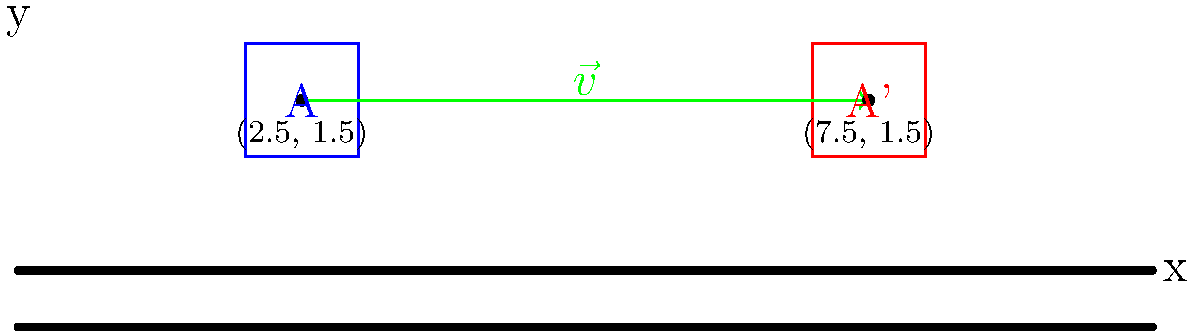A robotic gripper is initially positioned at point A(2.5, 1.5) on a conveyor belt system. The gripper needs to be translated to a new position A'(7.5, 1.5) to pick up an object. Determine the translation vector $\vec{v}$ that describes this movement and express it in component form. To find the translation vector $\vec{v}$, we need to follow these steps:

1) The translation vector $\vec{v}$ is the vector that moves the gripper from point A to point A'.

2) To calculate this vector, we subtract the initial position coordinates from the final position coordinates:

   $\vec{v} = A' - A$

3) Given:
   - Initial position A: (2.5, 1.5)
   - Final position A': (7.5, 1.5)

4) Calculate the x-component of $\vec{v}$:
   $v_x = 7.5 - 2.5 = 5$

5) Calculate the y-component of $\vec{v}$:
   $v_y = 1.5 - 1.5 = 0$

6) Express $\vec{v}$ in component form:
   $\vec{v} = \langle 5, 0 \rangle$

This vector indicates that the gripper moves 5 units in the positive x-direction and 0 units in the y-direction, which matches the horizontal movement shown in the diagram.
Answer: $\vec{v} = \langle 5, 0 \rangle$ 